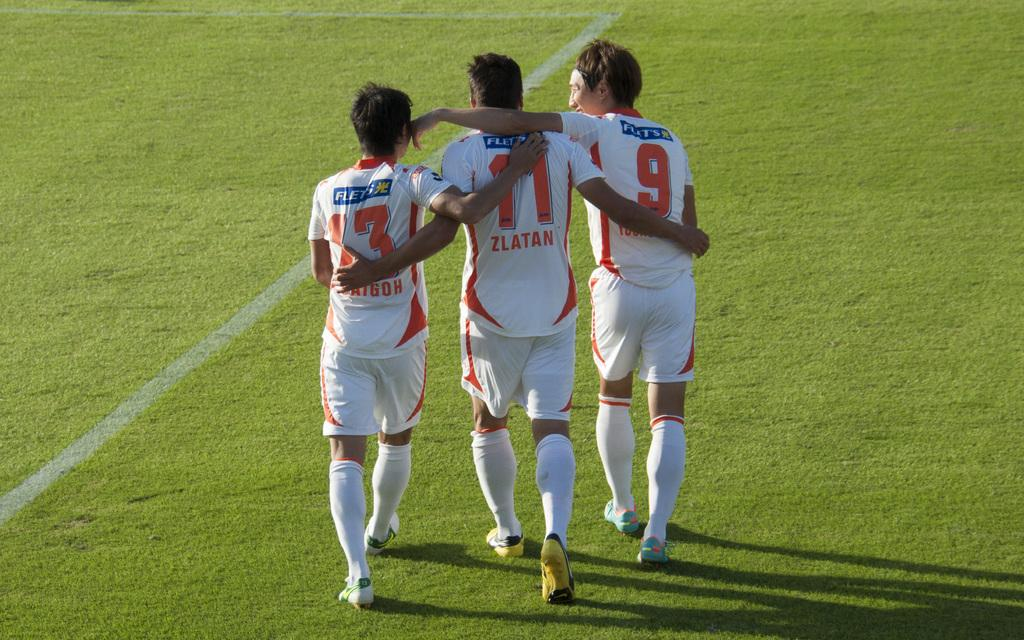How many men are present in the image? There are three men standing in the image. What are the men wearing on their upper bodies? The men are wearing jerseys in the image. What type of clothing are the men wearing on their lower bodies? The men are wearing shorts in the image. What type of footwear are the men wearing? The men are wearing shoes in the image. What type of surface is visible in the image? There is grass visible in the image. What can be observed on the ground in the image? There are shadows on the ground in the image. What type of suit is the mom wearing in the image? There is no mom or suit present in the image; it features three men wearing jerseys, shorts, and shoes. What idea does the image represent? The image does not represent an idea; it is a visual representation of three men standing on a grassy surface. 